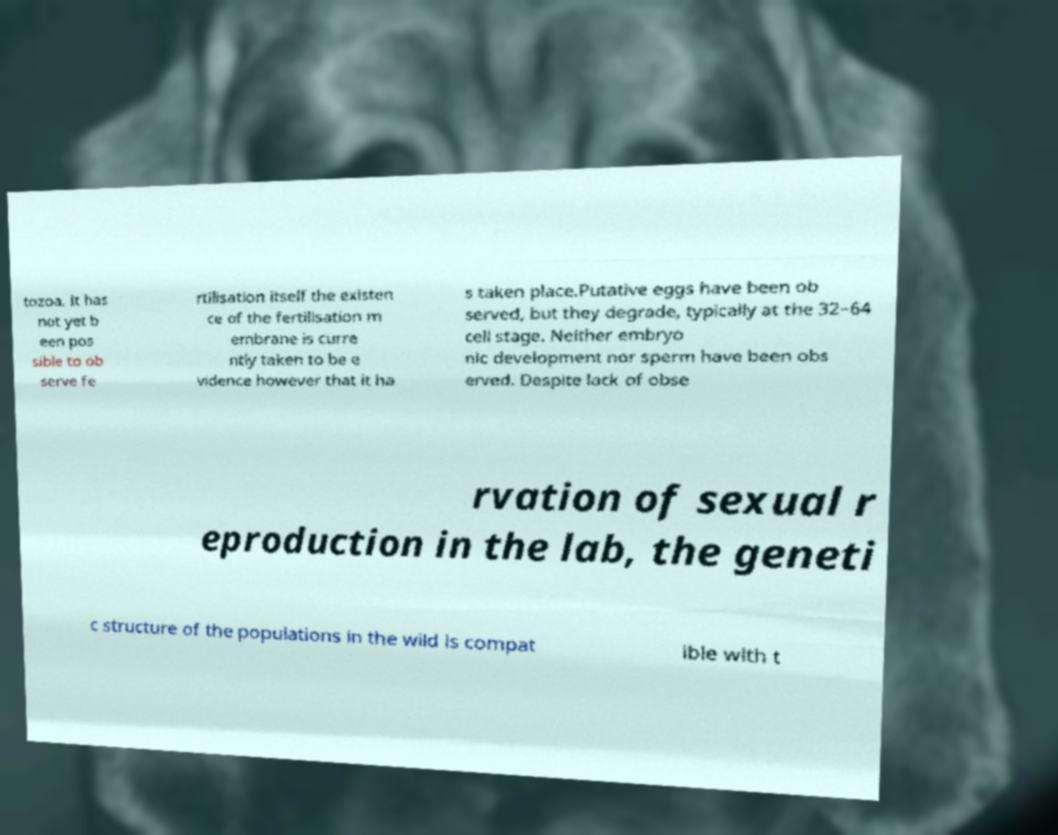Can you read and provide the text displayed in the image?This photo seems to have some interesting text. Can you extract and type it out for me? tozoa. It has not yet b een pos sible to ob serve fe rtilisation itself the existen ce of the fertilisation m embrane is curre ntly taken to be e vidence however that it ha s taken place.Putative eggs have been ob served, but they degrade, typically at the 32–64 cell stage. Neither embryo nic development nor sperm have been obs erved. Despite lack of obse rvation of sexual r eproduction in the lab, the geneti c structure of the populations in the wild is compat ible with t 